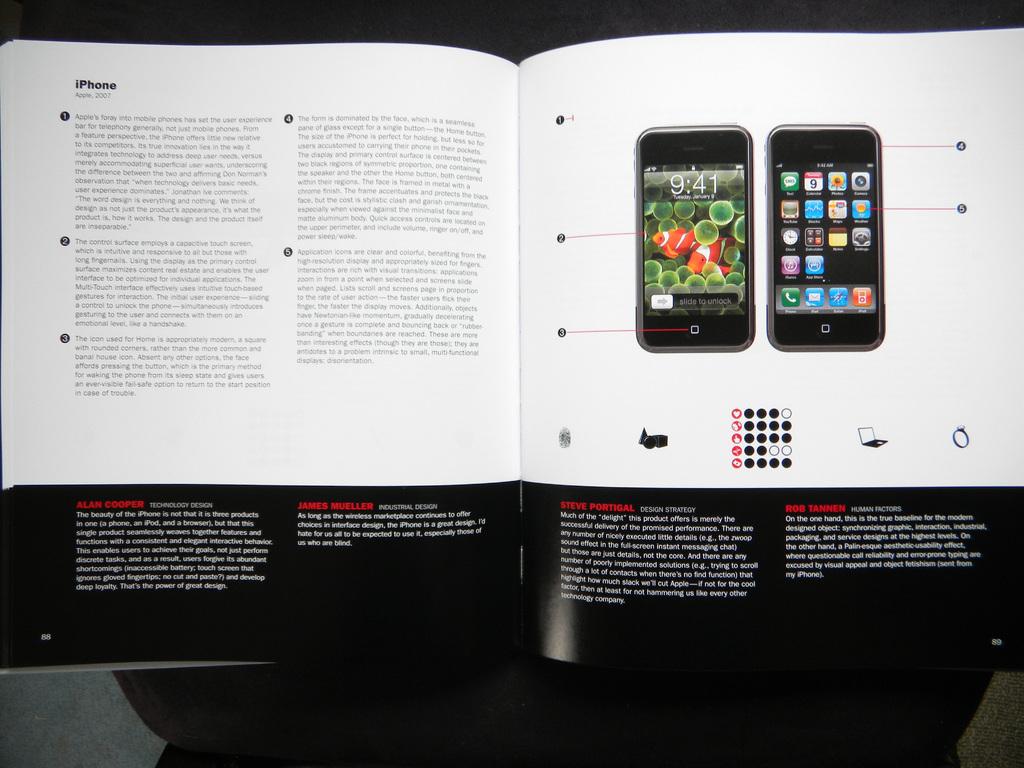What phone is the book featuring?
Your answer should be compact. Iphone. What time is shown on the phone?
Your answer should be very brief. 9:41. 